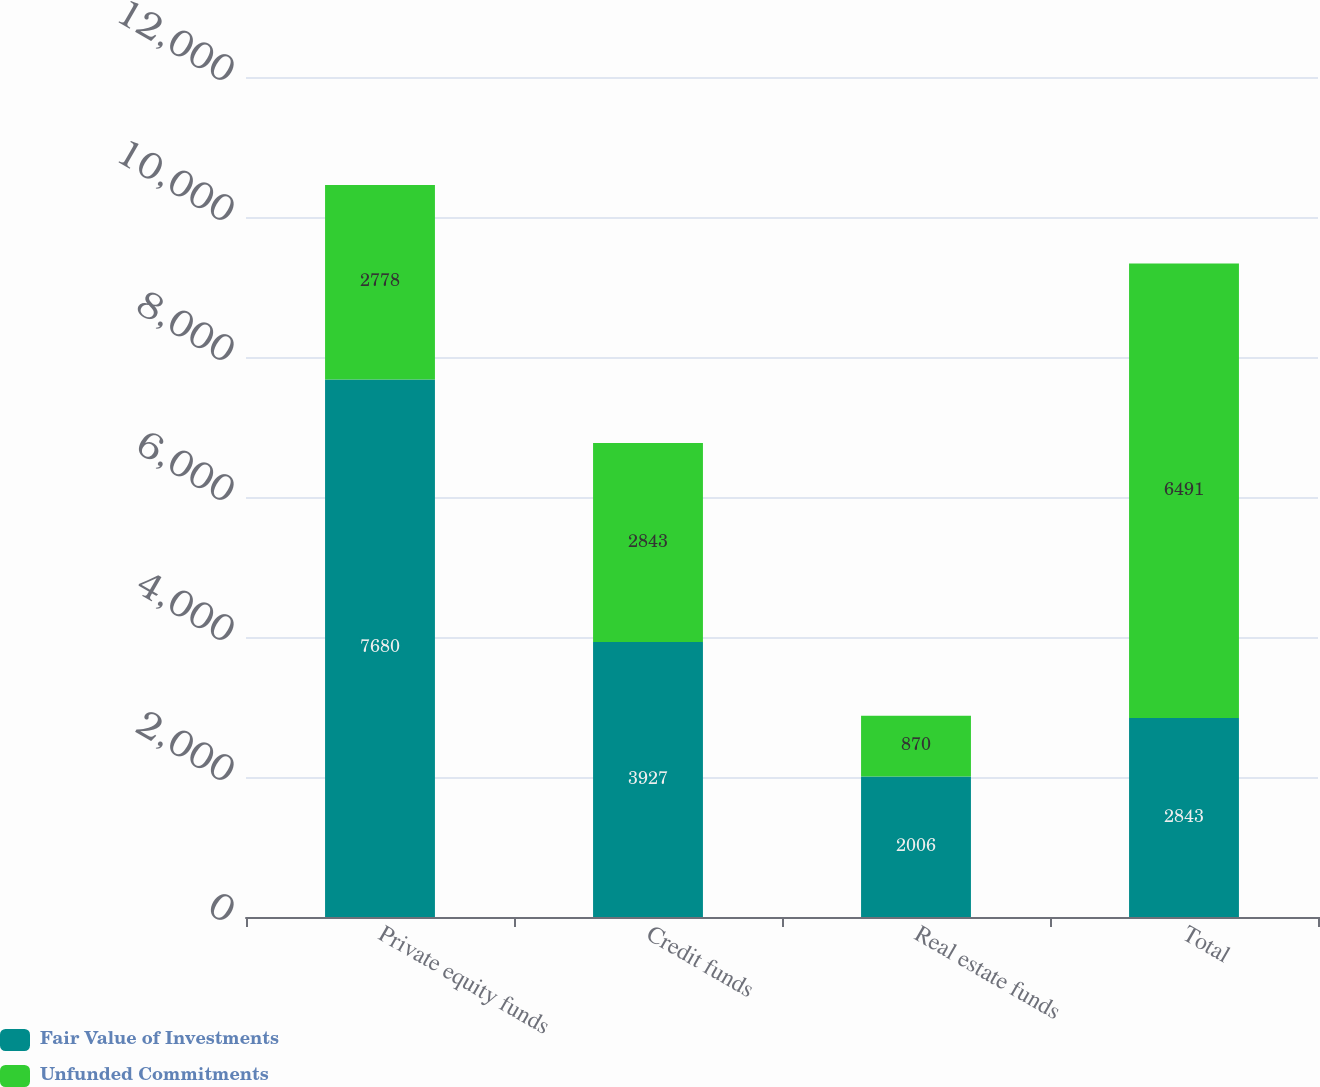Convert chart. <chart><loc_0><loc_0><loc_500><loc_500><stacked_bar_chart><ecel><fcel>Private equity funds<fcel>Credit funds<fcel>Real estate funds<fcel>Total<nl><fcel>Fair Value of Investments<fcel>7680<fcel>3927<fcel>2006<fcel>2843<nl><fcel>Unfunded Commitments<fcel>2778<fcel>2843<fcel>870<fcel>6491<nl></chart> 